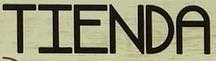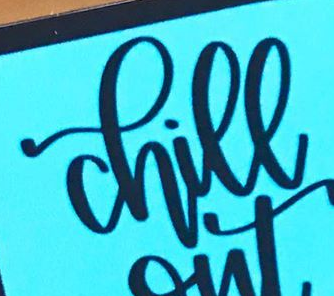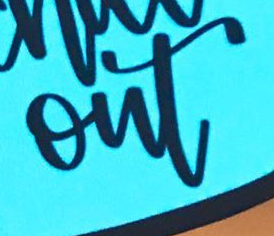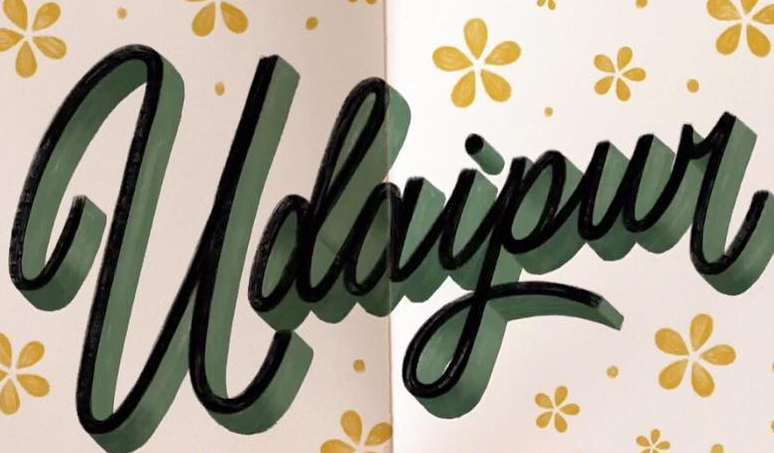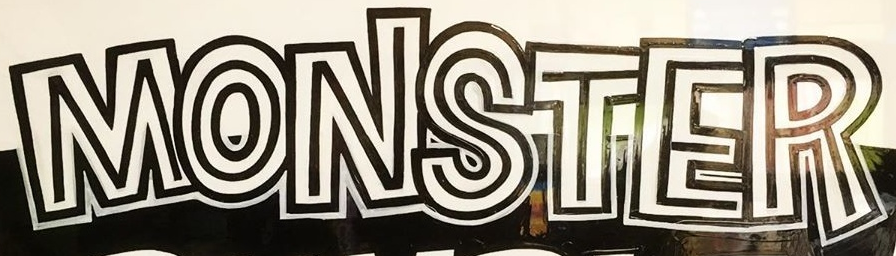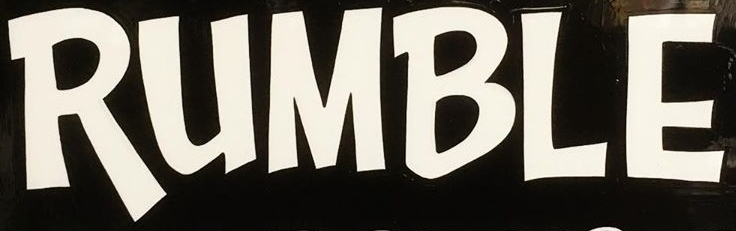Read the text content from these images in order, separated by a semicolon. TIENDA; chill; out; Udaipur; MONSTER; RUMBLE 